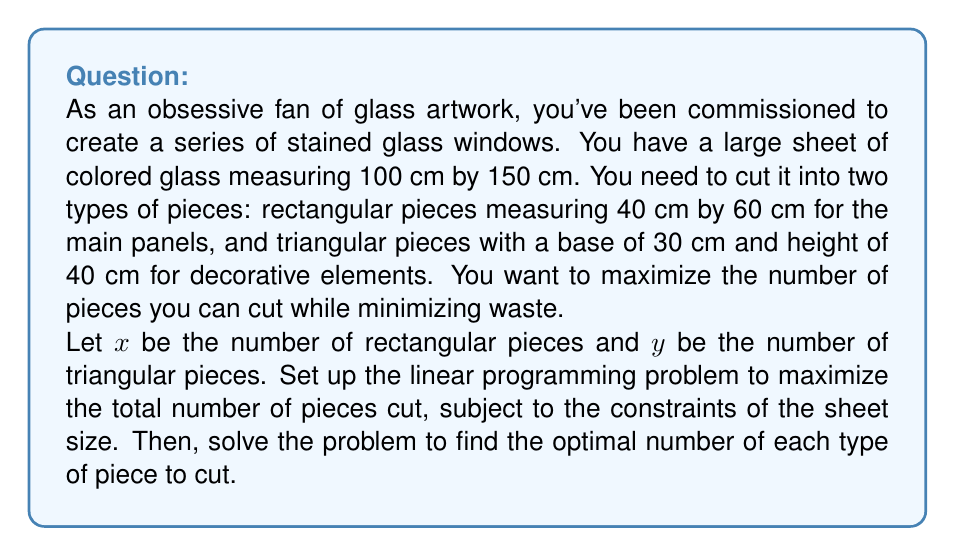Can you solve this math problem? Let's approach this problem step-by-step:

1) First, we need to set up our objective function. We want to maximize the total number of pieces, so our objective function is:

   Maximize: $z = x + y$

2) Now, we need to set up our constraints:

   a) Area constraint:
      - Area of a rectangular piece: $40 \times 60 = 2400$ cm²
      - Area of a triangular piece: $\frac{1}{2} \times 30 \times 40 = 600$ cm²
      - Total area of the sheet: $100 \times 150 = 15000$ cm²

      Constraint: $2400x + 600y \leq 15000$

   b) Non-negativity constraints:
      $x \geq 0$, $y \geq 0$

3) Simplify the area constraint:
   $4x + y \leq 25$

4) Our linear programming problem is now:

   Maximize: $z = x + y$
   Subject to:
   $4x + y \leq 25$
   $x \geq 0$, $y \geq 0$

5) To solve this, we can use the graphical method:

   [asy]
   import graph;
   size(200);
   xaxis("x", 0, 7);
   yaxis("y", 0, 30);
   draw((0,25)--(6.25,0), blue);
   draw((0,0)--(6.25,0)--(6.25,30), dashed);
   draw((0,0)--(0,30), dashed);
   label("4x + y = 25", (3,15), E);
   dot((0,25));
   dot((6.25,0));
   [/asy]

6) The feasible region is bounded by the x-axis, y-axis, and the line $4x + y = 25$.

7) The optimal solution will be at one of the corner points. We have three corner points:
   (0,0), (0,25), and (6.25,0)

8) Evaluating our objective function at these points:
   At (0,0): $z = 0 + 0 = 0$
   At (0,25): $z = 0 + 25 = 25$
   At (6.25,0): $z = 6.25 + 0 = 6.25$

9) The maximum value is at (0,25), but we need integer solutions.

10) The optimal integer solution is at (0,25), which means we should cut 25 triangular pieces and 0 rectangular pieces.
Answer: The optimal solution is to cut 25 triangular pieces and 0 rectangular pieces from the glass sheet. 